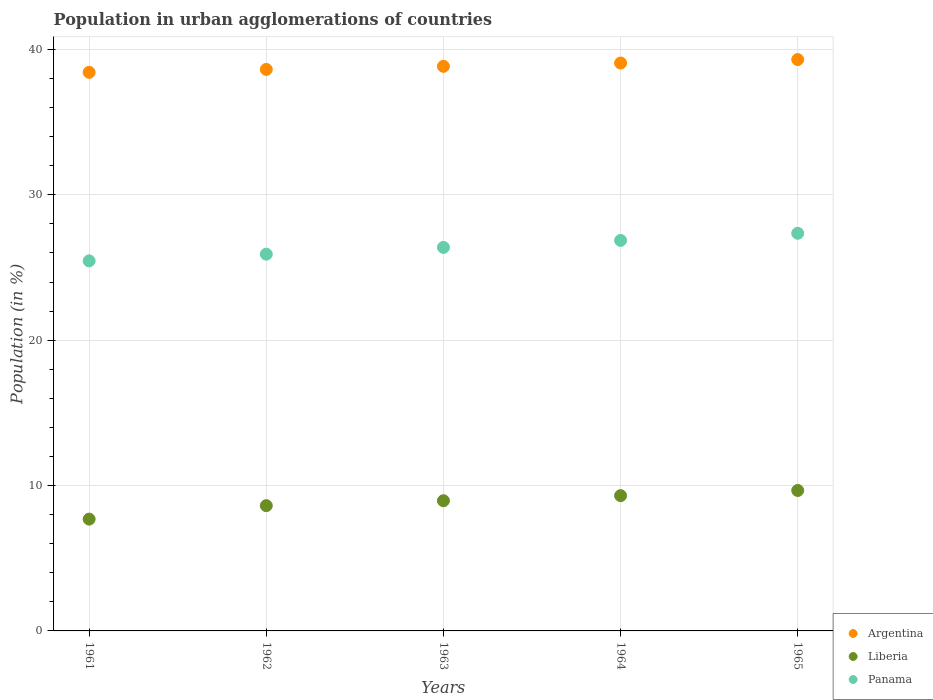How many different coloured dotlines are there?
Make the answer very short. 3. What is the percentage of population in urban agglomerations in Liberia in 1962?
Make the answer very short. 8.62. Across all years, what is the maximum percentage of population in urban agglomerations in Liberia?
Your answer should be compact. 9.66. Across all years, what is the minimum percentage of population in urban agglomerations in Panama?
Your answer should be very brief. 25.46. In which year was the percentage of population in urban agglomerations in Liberia maximum?
Provide a succinct answer. 1965. What is the total percentage of population in urban agglomerations in Panama in the graph?
Offer a terse response. 131.97. What is the difference between the percentage of population in urban agglomerations in Argentina in 1961 and that in 1965?
Provide a succinct answer. -0.88. What is the difference between the percentage of population in urban agglomerations in Liberia in 1961 and the percentage of population in urban agglomerations in Argentina in 1963?
Keep it short and to the point. -31.14. What is the average percentage of population in urban agglomerations in Liberia per year?
Provide a short and direct response. 8.85. In the year 1964, what is the difference between the percentage of population in urban agglomerations in Panama and percentage of population in urban agglomerations in Argentina?
Your answer should be compact. -12.2. What is the ratio of the percentage of population in urban agglomerations in Panama in 1961 to that in 1963?
Provide a short and direct response. 0.96. Is the percentage of population in urban agglomerations in Panama in 1963 less than that in 1964?
Ensure brevity in your answer.  Yes. What is the difference between the highest and the second highest percentage of population in urban agglomerations in Panama?
Make the answer very short. 0.49. What is the difference between the highest and the lowest percentage of population in urban agglomerations in Liberia?
Provide a succinct answer. 1.97. Is the sum of the percentage of population in urban agglomerations in Liberia in 1962 and 1963 greater than the maximum percentage of population in urban agglomerations in Argentina across all years?
Your answer should be compact. No. Is it the case that in every year, the sum of the percentage of population in urban agglomerations in Liberia and percentage of population in urban agglomerations in Panama  is greater than the percentage of population in urban agglomerations in Argentina?
Your answer should be compact. No. Does the percentage of population in urban agglomerations in Argentina monotonically increase over the years?
Ensure brevity in your answer.  Yes. Is the percentage of population in urban agglomerations in Panama strictly greater than the percentage of population in urban agglomerations in Argentina over the years?
Keep it short and to the point. No. How many years are there in the graph?
Give a very brief answer. 5. What is the difference between two consecutive major ticks on the Y-axis?
Provide a succinct answer. 10. Are the values on the major ticks of Y-axis written in scientific E-notation?
Provide a succinct answer. No. Where does the legend appear in the graph?
Your response must be concise. Bottom right. How many legend labels are there?
Offer a terse response. 3. How are the legend labels stacked?
Your answer should be compact. Vertical. What is the title of the graph?
Offer a terse response. Population in urban agglomerations of countries. What is the label or title of the X-axis?
Your answer should be very brief. Years. What is the label or title of the Y-axis?
Your answer should be very brief. Population (in %). What is the Population (in %) in Argentina in 1961?
Your answer should be compact. 38.42. What is the Population (in %) in Liberia in 1961?
Provide a short and direct response. 7.69. What is the Population (in %) in Panama in 1961?
Make the answer very short. 25.46. What is the Population (in %) of Argentina in 1962?
Your answer should be compact. 38.62. What is the Population (in %) in Liberia in 1962?
Provide a succinct answer. 8.62. What is the Population (in %) of Panama in 1962?
Make the answer very short. 25.92. What is the Population (in %) in Argentina in 1963?
Provide a succinct answer. 38.84. What is the Population (in %) in Liberia in 1963?
Your response must be concise. 8.96. What is the Population (in %) of Panama in 1963?
Offer a terse response. 26.38. What is the Population (in %) of Argentina in 1964?
Provide a short and direct response. 39.06. What is the Population (in %) of Liberia in 1964?
Keep it short and to the point. 9.31. What is the Population (in %) of Panama in 1964?
Your answer should be compact. 26.86. What is the Population (in %) of Argentina in 1965?
Your response must be concise. 39.3. What is the Population (in %) of Liberia in 1965?
Your answer should be compact. 9.66. What is the Population (in %) of Panama in 1965?
Provide a succinct answer. 27.35. Across all years, what is the maximum Population (in %) in Argentina?
Offer a very short reply. 39.3. Across all years, what is the maximum Population (in %) of Liberia?
Your response must be concise. 9.66. Across all years, what is the maximum Population (in %) in Panama?
Make the answer very short. 27.35. Across all years, what is the minimum Population (in %) in Argentina?
Give a very brief answer. 38.42. Across all years, what is the minimum Population (in %) in Liberia?
Give a very brief answer. 7.69. Across all years, what is the minimum Population (in %) of Panama?
Offer a terse response. 25.46. What is the total Population (in %) in Argentina in the graph?
Your answer should be very brief. 194.25. What is the total Population (in %) in Liberia in the graph?
Ensure brevity in your answer.  44.23. What is the total Population (in %) of Panama in the graph?
Keep it short and to the point. 131.97. What is the difference between the Population (in %) in Argentina in 1961 and that in 1962?
Your answer should be compact. -0.2. What is the difference between the Population (in %) of Liberia in 1961 and that in 1962?
Your response must be concise. -0.93. What is the difference between the Population (in %) of Panama in 1961 and that in 1962?
Give a very brief answer. -0.46. What is the difference between the Population (in %) in Argentina in 1961 and that in 1963?
Keep it short and to the point. -0.41. What is the difference between the Population (in %) in Liberia in 1961 and that in 1963?
Offer a very short reply. -1.26. What is the difference between the Population (in %) in Panama in 1961 and that in 1963?
Your answer should be compact. -0.93. What is the difference between the Population (in %) of Argentina in 1961 and that in 1964?
Your answer should be compact. -0.64. What is the difference between the Population (in %) of Liberia in 1961 and that in 1964?
Provide a short and direct response. -1.61. What is the difference between the Population (in %) of Panama in 1961 and that in 1964?
Offer a terse response. -1.41. What is the difference between the Population (in %) of Argentina in 1961 and that in 1965?
Offer a very short reply. -0.88. What is the difference between the Population (in %) in Liberia in 1961 and that in 1965?
Offer a terse response. -1.97. What is the difference between the Population (in %) in Panama in 1961 and that in 1965?
Ensure brevity in your answer.  -1.9. What is the difference between the Population (in %) in Argentina in 1962 and that in 1963?
Offer a terse response. -0.21. What is the difference between the Population (in %) of Liberia in 1962 and that in 1963?
Offer a very short reply. -0.34. What is the difference between the Population (in %) of Panama in 1962 and that in 1963?
Make the answer very short. -0.47. What is the difference between the Population (in %) of Argentina in 1962 and that in 1964?
Ensure brevity in your answer.  -0.44. What is the difference between the Population (in %) in Liberia in 1962 and that in 1964?
Make the answer very short. -0.69. What is the difference between the Population (in %) in Panama in 1962 and that in 1964?
Offer a terse response. -0.95. What is the difference between the Population (in %) of Argentina in 1962 and that in 1965?
Provide a succinct answer. -0.68. What is the difference between the Population (in %) of Liberia in 1962 and that in 1965?
Your answer should be very brief. -1.04. What is the difference between the Population (in %) in Panama in 1962 and that in 1965?
Ensure brevity in your answer.  -1.44. What is the difference between the Population (in %) in Argentina in 1963 and that in 1964?
Make the answer very short. -0.23. What is the difference between the Population (in %) of Liberia in 1963 and that in 1964?
Ensure brevity in your answer.  -0.35. What is the difference between the Population (in %) of Panama in 1963 and that in 1964?
Offer a very short reply. -0.48. What is the difference between the Population (in %) of Argentina in 1963 and that in 1965?
Ensure brevity in your answer.  -0.47. What is the difference between the Population (in %) of Liberia in 1963 and that in 1965?
Your answer should be compact. -0.7. What is the difference between the Population (in %) in Panama in 1963 and that in 1965?
Your answer should be very brief. -0.97. What is the difference between the Population (in %) in Argentina in 1964 and that in 1965?
Provide a short and direct response. -0.24. What is the difference between the Population (in %) of Liberia in 1964 and that in 1965?
Offer a very short reply. -0.36. What is the difference between the Population (in %) in Panama in 1964 and that in 1965?
Provide a short and direct response. -0.49. What is the difference between the Population (in %) in Argentina in 1961 and the Population (in %) in Liberia in 1962?
Offer a very short reply. 29.81. What is the difference between the Population (in %) of Argentina in 1961 and the Population (in %) of Panama in 1962?
Ensure brevity in your answer.  12.51. What is the difference between the Population (in %) of Liberia in 1961 and the Population (in %) of Panama in 1962?
Provide a succinct answer. -18.22. What is the difference between the Population (in %) in Argentina in 1961 and the Population (in %) in Liberia in 1963?
Offer a very short reply. 29.47. What is the difference between the Population (in %) of Argentina in 1961 and the Population (in %) of Panama in 1963?
Make the answer very short. 12.04. What is the difference between the Population (in %) in Liberia in 1961 and the Population (in %) in Panama in 1963?
Offer a very short reply. -18.69. What is the difference between the Population (in %) in Argentina in 1961 and the Population (in %) in Liberia in 1964?
Your answer should be compact. 29.12. What is the difference between the Population (in %) of Argentina in 1961 and the Population (in %) of Panama in 1964?
Your answer should be very brief. 11.56. What is the difference between the Population (in %) in Liberia in 1961 and the Population (in %) in Panama in 1964?
Your response must be concise. -19.17. What is the difference between the Population (in %) in Argentina in 1961 and the Population (in %) in Liberia in 1965?
Make the answer very short. 28.76. What is the difference between the Population (in %) of Argentina in 1961 and the Population (in %) of Panama in 1965?
Keep it short and to the point. 11.07. What is the difference between the Population (in %) of Liberia in 1961 and the Population (in %) of Panama in 1965?
Give a very brief answer. -19.66. What is the difference between the Population (in %) of Argentina in 1962 and the Population (in %) of Liberia in 1963?
Give a very brief answer. 29.67. What is the difference between the Population (in %) of Argentina in 1962 and the Population (in %) of Panama in 1963?
Give a very brief answer. 12.24. What is the difference between the Population (in %) in Liberia in 1962 and the Population (in %) in Panama in 1963?
Ensure brevity in your answer.  -17.77. What is the difference between the Population (in %) in Argentina in 1962 and the Population (in %) in Liberia in 1964?
Make the answer very short. 29.32. What is the difference between the Population (in %) of Argentina in 1962 and the Population (in %) of Panama in 1964?
Your answer should be compact. 11.76. What is the difference between the Population (in %) of Liberia in 1962 and the Population (in %) of Panama in 1964?
Your answer should be compact. -18.25. What is the difference between the Population (in %) of Argentina in 1962 and the Population (in %) of Liberia in 1965?
Ensure brevity in your answer.  28.96. What is the difference between the Population (in %) in Argentina in 1962 and the Population (in %) in Panama in 1965?
Give a very brief answer. 11.27. What is the difference between the Population (in %) of Liberia in 1962 and the Population (in %) of Panama in 1965?
Make the answer very short. -18.74. What is the difference between the Population (in %) in Argentina in 1963 and the Population (in %) in Liberia in 1964?
Provide a short and direct response. 29.53. What is the difference between the Population (in %) in Argentina in 1963 and the Population (in %) in Panama in 1964?
Your answer should be very brief. 11.97. What is the difference between the Population (in %) of Liberia in 1963 and the Population (in %) of Panama in 1964?
Keep it short and to the point. -17.91. What is the difference between the Population (in %) in Argentina in 1963 and the Population (in %) in Liberia in 1965?
Keep it short and to the point. 29.18. What is the difference between the Population (in %) in Argentina in 1963 and the Population (in %) in Panama in 1965?
Provide a short and direct response. 11.48. What is the difference between the Population (in %) in Liberia in 1963 and the Population (in %) in Panama in 1965?
Provide a succinct answer. -18.4. What is the difference between the Population (in %) of Argentina in 1964 and the Population (in %) of Liberia in 1965?
Your answer should be very brief. 29.4. What is the difference between the Population (in %) of Argentina in 1964 and the Population (in %) of Panama in 1965?
Your answer should be compact. 11.71. What is the difference between the Population (in %) in Liberia in 1964 and the Population (in %) in Panama in 1965?
Your answer should be very brief. -18.05. What is the average Population (in %) in Argentina per year?
Ensure brevity in your answer.  38.85. What is the average Population (in %) of Liberia per year?
Your response must be concise. 8.85. What is the average Population (in %) in Panama per year?
Your answer should be compact. 26.39. In the year 1961, what is the difference between the Population (in %) of Argentina and Population (in %) of Liberia?
Give a very brief answer. 30.73. In the year 1961, what is the difference between the Population (in %) of Argentina and Population (in %) of Panama?
Your response must be concise. 12.97. In the year 1961, what is the difference between the Population (in %) in Liberia and Population (in %) in Panama?
Make the answer very short. -17.76. In the year 1962, what is the difference between the Population (in %) in Argentina and Population (in %) in Liberia?
Your answer should be very brief. 30.01. In the year 1962, what is the difference between the Population (in %) in Argentina and Population (in %) in Panama?
Ensure brevity in your answer.  12.71. In the year 1962, what is the difference between the Population (in %) in Liberia and Population (in %) in Panama?
Provide a succinct answer. -17.3. In the year 1963, what is the difference between the Population (in %) in Argentina and Population (in %) in Liberia?
Offer a terse response. 29.88. In the year 1963, what is the difference between the Population (in %) in Argentina and Population (in %) in Panama?
Your answer should be compact. 12.45. In the year 1963, what is the difference between the Population (in %) of Liberia and Population (in %) of Panama?
Your response must be concise. -17.43. In the year 1964, what is the difference between the Population (in %) in Argentina and Population (in %) in Liberia?
Give a very brief answer. 29.76. In the year 1964, what is the difference between the Population (in %) in Argentina and Population (in %) in Panama?
Keep it short and to the point. 12.2. In the year 1964, what is the difference between the Population (in %) of Liberia and Population (in %) of Panama?
Offer a terse response. -17.56. In the year 1965, what is the difference between the Population (in %) of Argentina and Population (in %) of Liberia?
Your answer should be compact. 29.64. In the year 1965, what is the difference between the Population (in %) in Argentina and Population (in %) in Panama?
Ensure brevity in your answer.  11.95. In the year 1965, what is the difference between the Population (in %) in Liberia and Population (in %) in Panama?
Give a very brief answer. -17.69. What is the ratio of the Population (in %) of Liberia in 1961 to that in 1962?
Make the answer very short. 0.89. What is the ratio of the Population (in %) in Panama in 1961 to that in 1962?
Provide a succinct answer. 0.98. What is the ratio of the Population (in %) of Argentina in 1961 to that in 1963?
Your response must be concise. 0.99. What is the ratio of the Population (in %) in Liberia in 1961 to that in 1963?
Keep it short and to the point. 0.86. What is the ratio of the Population (in %) in Panama in 1961 to that in 1963?
Ensure brevity in your answer.  0.96. What is the ratio of the Population (in %) in Argentina in 1961 to that in 1964?
Offer a terse response. 0.98. What is the ratio of the Population (in %) of Liberia in 1961 to that in 1964?
Offer a terse response. 0.83. What is the ratio of the Population (in %) of Panama in 1961 to that in 1964?
Provide a succinct answer. 0.95. What is the ratio of the Population (in %) in Argentina in 1961 to that in 1965?
Make the answer very short. 0.98. What is the ratio of the Population (in %) in Liberia in 1961 to that in 1965?
Make the answer very short. 0.8. What is the ratio of the Population (in %) in Panama in 1961 to that in 1965?
Provide a short and direct response. 0.93. What is the ratio of the Population (in %) in Liberia in 1962 to that in 1963?
Ensure brevity in your answer.  0.96. What is the ratio of the Population (in %) in Panama in 1962 to that in 1963?
Keep it short and to the point. 0.98. What is the ratio of the Population (in %) of Liberia in 1962 to that in 1964?
Provide a short and direct response. 0.93. What is the ratio of the Population (in %) in Panama in 1962 to that in 1964?
Offer a very short reply. 0.96. What is the ratio of the Population (in %) in Argentina in 1962 to that in 1965?
Provide a succinct answer. 0.98. What is the ratio of the Population (in %) of Liberia in 1962 to that in 1965?
Give a very brief answer. 0.89. What is the ratio of the Population (in %) of Panama in 1962 to that in 1965?
Provide a short and direct response. 0.95. What is the ratio of the Population (in %) in Argentina in 1963 to that in 1964?
Offer a terse response. 0.99. What is the ratio of the Population (in %) of Liberia in 1963 to that in 1964?
Ensure brevity in your answer.  0.96. What is the ratio of the Population (in %) in Panama in 1963 to that in 1964?
Ensure brevity in your answer.  0.98. What is the ratio of the Population (in %) of Argentina in 1963 to that in 1965?
Keep it short and to the point. 0.99. What is the ratio of the Population (in %) of Liberia in 1963 to that in 1965?
Provide a short and direct response. 0.93. What is the ratio of the Population (in %) in Panama in 1963 to that in 1965?
Make the answer very short. 0.96. What is the ratio of the Population (in %) in Liberia in 1964 to that in 1965?
Give a very brief answer. 0.96. What is the ratio of the Population (in %) in Panama in 1964 to that in 1965?
Provide a succinct answer. 0.98. What is the difference between the highest and the second highest Population (in %) in Argentina?
Your answer should be compact. 0.24. What is the difference between the highest and the second highest Population (in %) in Liberia?
Provide a short and direct response. 0.36. What is the difference between the highest and the second highest Population (in %) of Panama?
Offer a very short reply. 0.49. What is the difference between the highest and the lowest Population (in %) of Argentina?
Your answer should be very brief. 0.88. What is the difference between the highest and the lowest Population (in %) of Liberia?
Offer a terse response. 1.97. What is the difference between the highest and the lowest Population (in %) in Panama?
Provide a short and direct response. 1.9. 